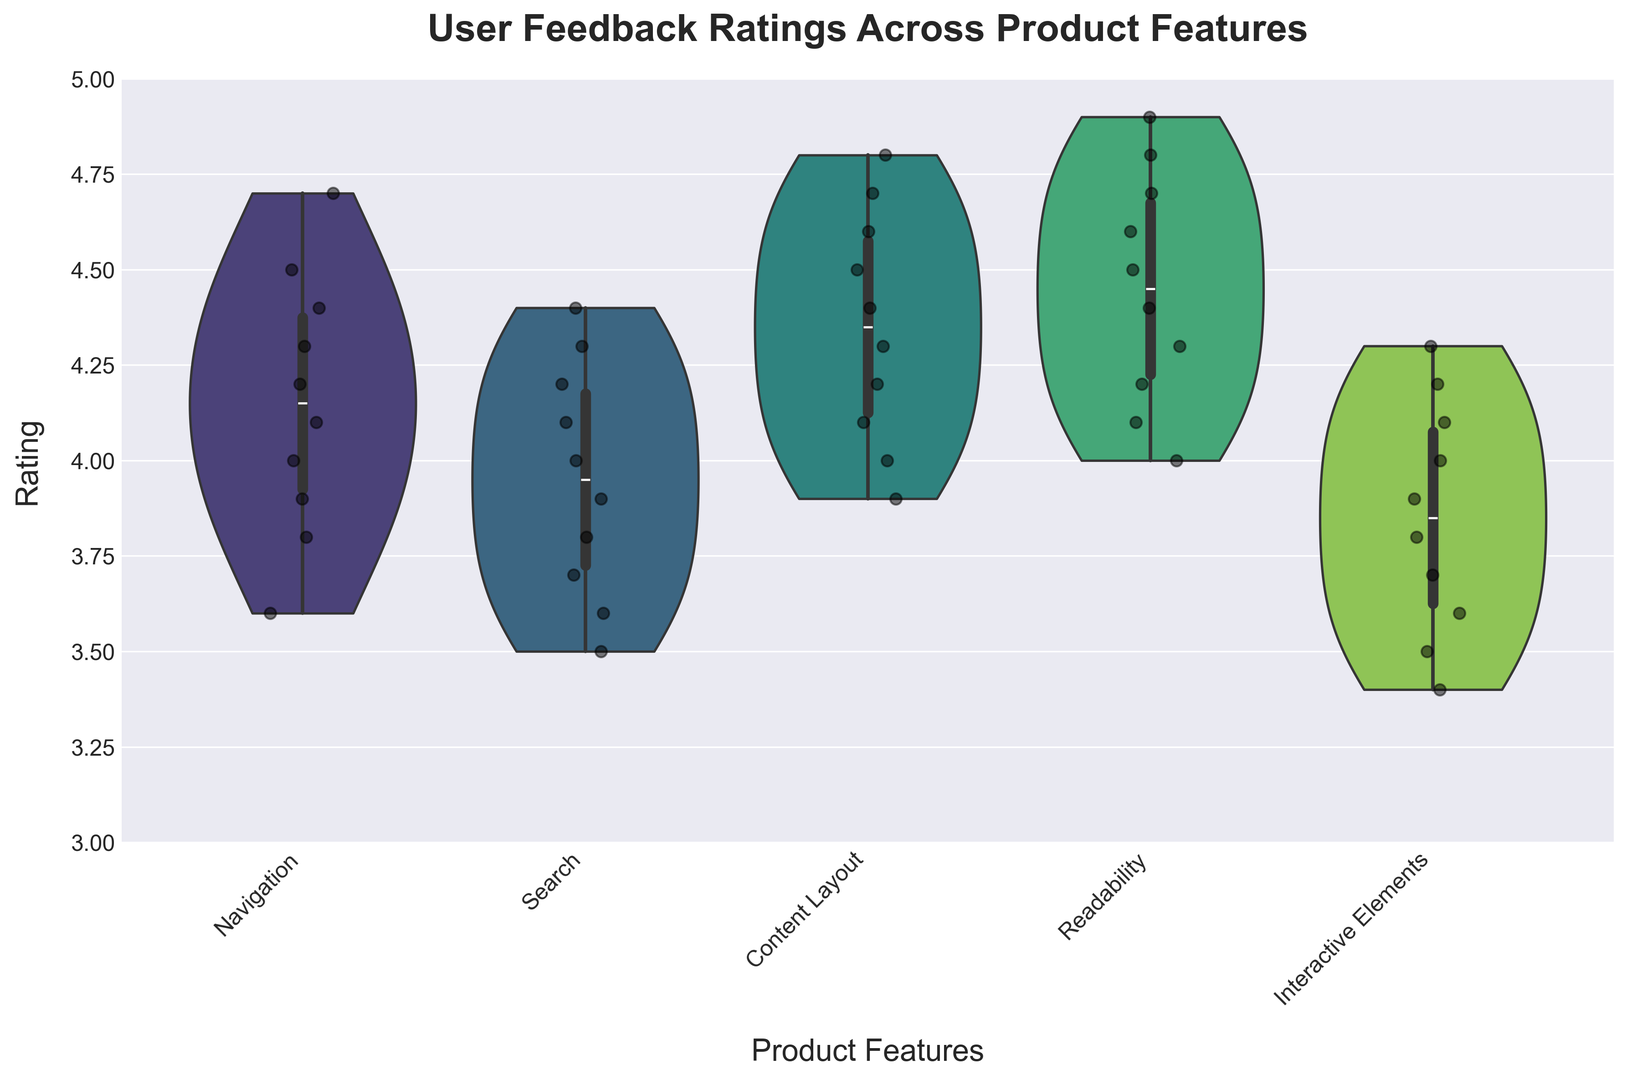Which feature has the highest median rating? To find the feature with the highest median rating, look at the central horizontal line in the widest part of the violin plots. The feature with the highest one is "Readability".
Answer: Readability What is the range of ratings for the "Navigation" feature? The range is determined by the minimum and maximum points in the violin plot for "Navigation". The ratings range from approximately 3.6 to 4.7.
Answer: 3.6 to 4.7 Which feature shows the most variability in ratings? Variability is indicated by the spread of the violin plot. The feature with the widest violin plot from top to bottom showing the greatest spread in ratings is "Interactive Elements".
Answer: Interactive Elements How does the rating distribution of "Search" compare with "Content Layout"? Compare the shape and spread of the violin plots for "Search" and "Content Layout". "Search" has a narrower spread and lower median compared to "Content Layout", which shows a higher median and wider spread.
Answer: "Content Layout" has a higher median and wider spread Which feature has the lowest median rating? Look for the central line in the middle of the smallest spread of ratings across features. "Interactive Elements" has the lowest median rating.
Answer: Interactive Elements What's the average rating for the "Readability" feature? Sum the individual ratings for "Readability" (4.6, 4.3, 4.8, 4.1, 4.5, 4.7, 4.2, 4.4, 4.0, 4.9) and divide by the number of ratings (10). (4.6+4.3+4.8+4.1+4.5+4.7+4.2+4.4+4.0+4.9) / 10 = 44.5 / 10 = 4.45
Answer: 4.45 Between "Navigation" and "Readability", which has more closely clustered user feedback? This is determined by examining the spread of the respective violin plots. "Readability" has more closely clustered ratings compared to "Navigation".
Answer: Readability 